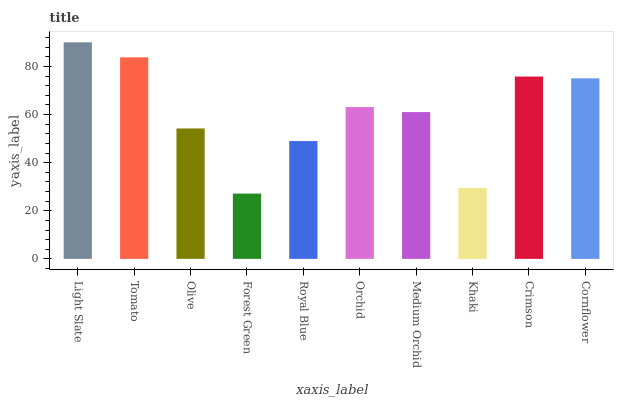Is Tomato the minimum?
Answer yes or no. No. Is Tomato the maximum?
Answer yes or no. No. Is Light Slate greater than Tomato?
Answer yes or no. Yes. Is Tomato less than Light Slate?
Answer yes or no. Yes. Is Tomato greater than Light Slate?
Answer yes or no. No. Is Light Slate less than Tomato?
Answer yes or no. No. Is Orchid the high median?
Answer yes or no. Yes. Is Medium Orchid the low median?
Answer yes or no. Yes. Is Light Slate the high median?
Answer yes or no. No. Is Forest Green the low median?
Answer yes or no. No. 